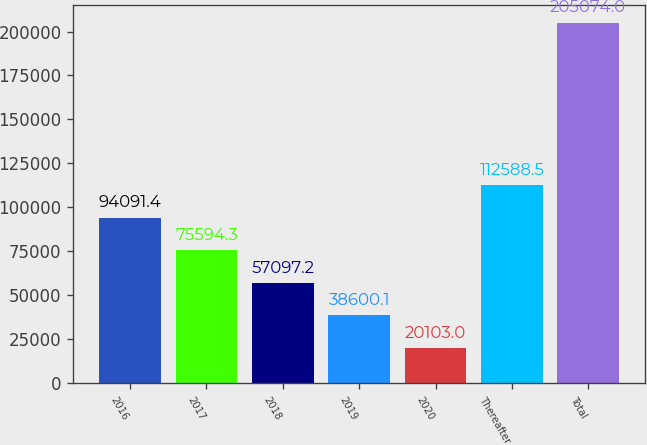Convert chart to OTSL. <chart><loc_0><loc_0><loc_500><loc_500><bar_chart><fcel>2016<fcel>2017<fcel>2018<fcel>2019<fcel>2020<fcel>Thereafter<fcel>Total<nl><fcel>94091.4<fcel>75594.3<fcel>57097.2<fcel>38600.1<fcel>20103<fcel>112588<fcel>205074<nl></chart> 